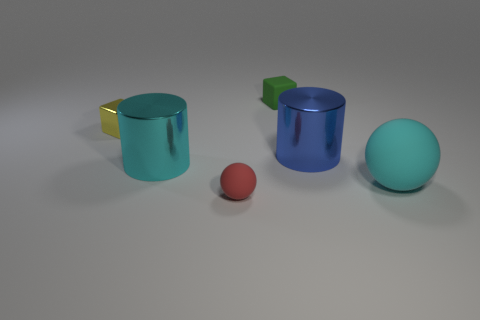What is the shape of the large shiny thing that is behind the big cylinder that is left of the big blue metallic cylinder?
Your answer should be compact. Cylinder. There is a rubber sphere on the left side of the matte block; does it have the same size as the cyan thing that is behind the cyan rubber ball?
Give a very brief answer. No. Is there a big cyan sphere made of the same material as the tiny green object?
Keep it short and to the point. Yes. There is a metallic object that is the same color as the big matte thing; what size is it?
Offer a terse response. Large. There is a object behind the small shiny object behind the small matte sphere; is there a matte ball that is left of it?
Provide a short and direct response. Yes. There is a large sphere; are there any matte spheres in front of it?
Offer a very short reply. Yes. How many large cylinders are on the left side of the small rubber thing that is on the left side of the tiny green rubber thing?
Ensure brevity in your answer.  1. There is a blue object; is its size the same as the rubber ball that is on the left side of the blue shiny cylinder?
Ensure brevity in your answer.  No. Is there a shiny cylinder of the same color as the big rubber sphere?
Make the answer very short. Yes. What size is the cyan thing that is made of the same material as the small yellow object?
Your response must be concise. Large. 